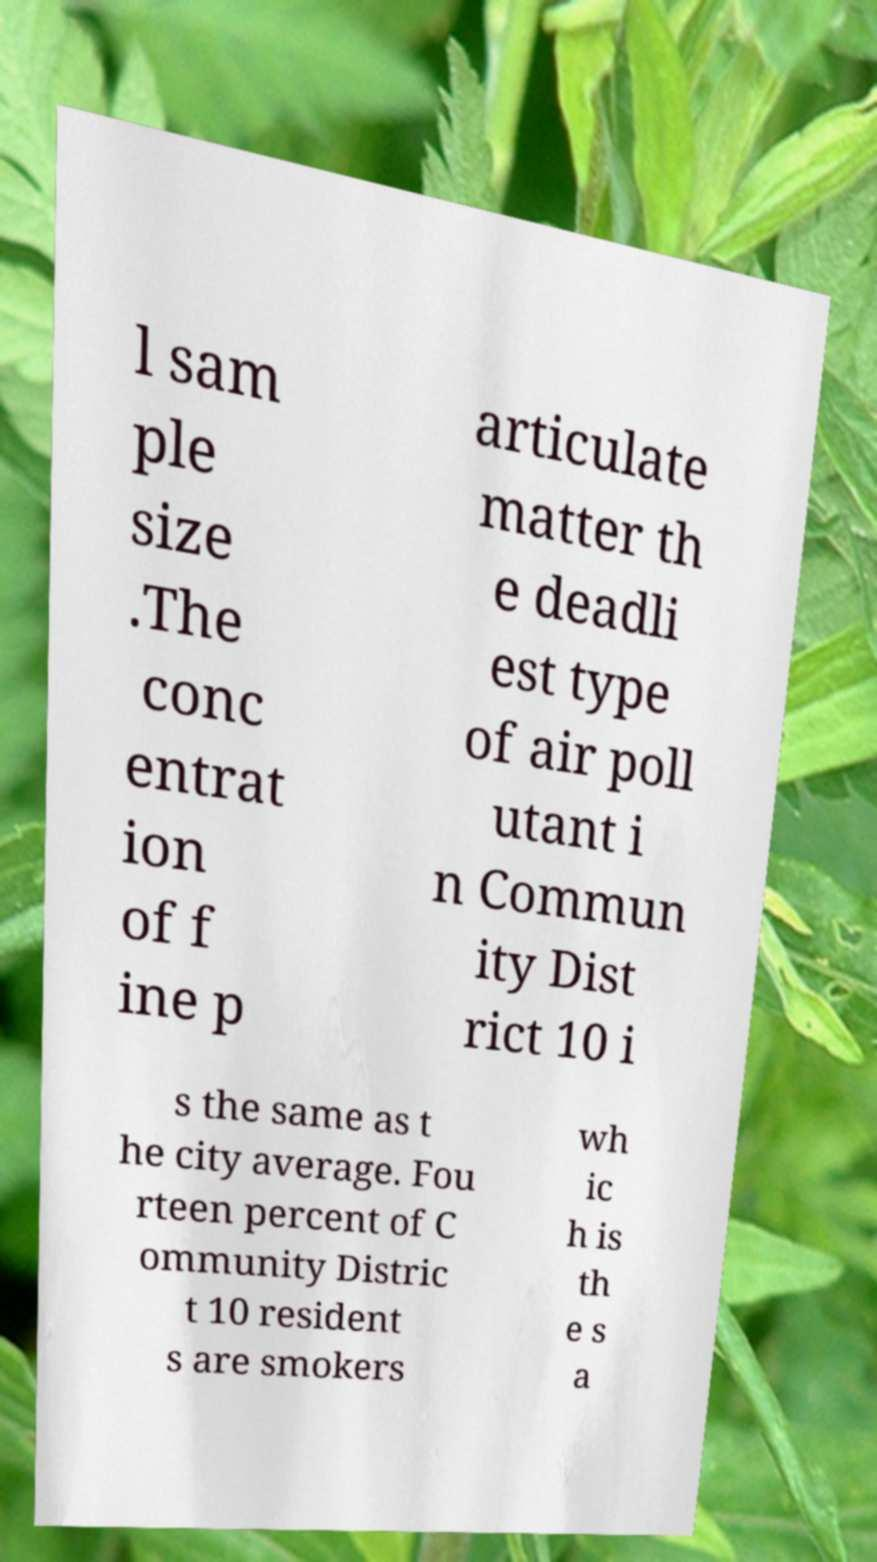Please identify and transcribe the text found in this image. l sam ple size .The conc entrat ion of f ine p articulate matter th e deadli est type of air poll utant i n Commun ity Dist rict 10 i s the same as t he city average. Fou rteen percent of C ommunity Distric t 10 resident s are smokers wh ic h is th e s a 